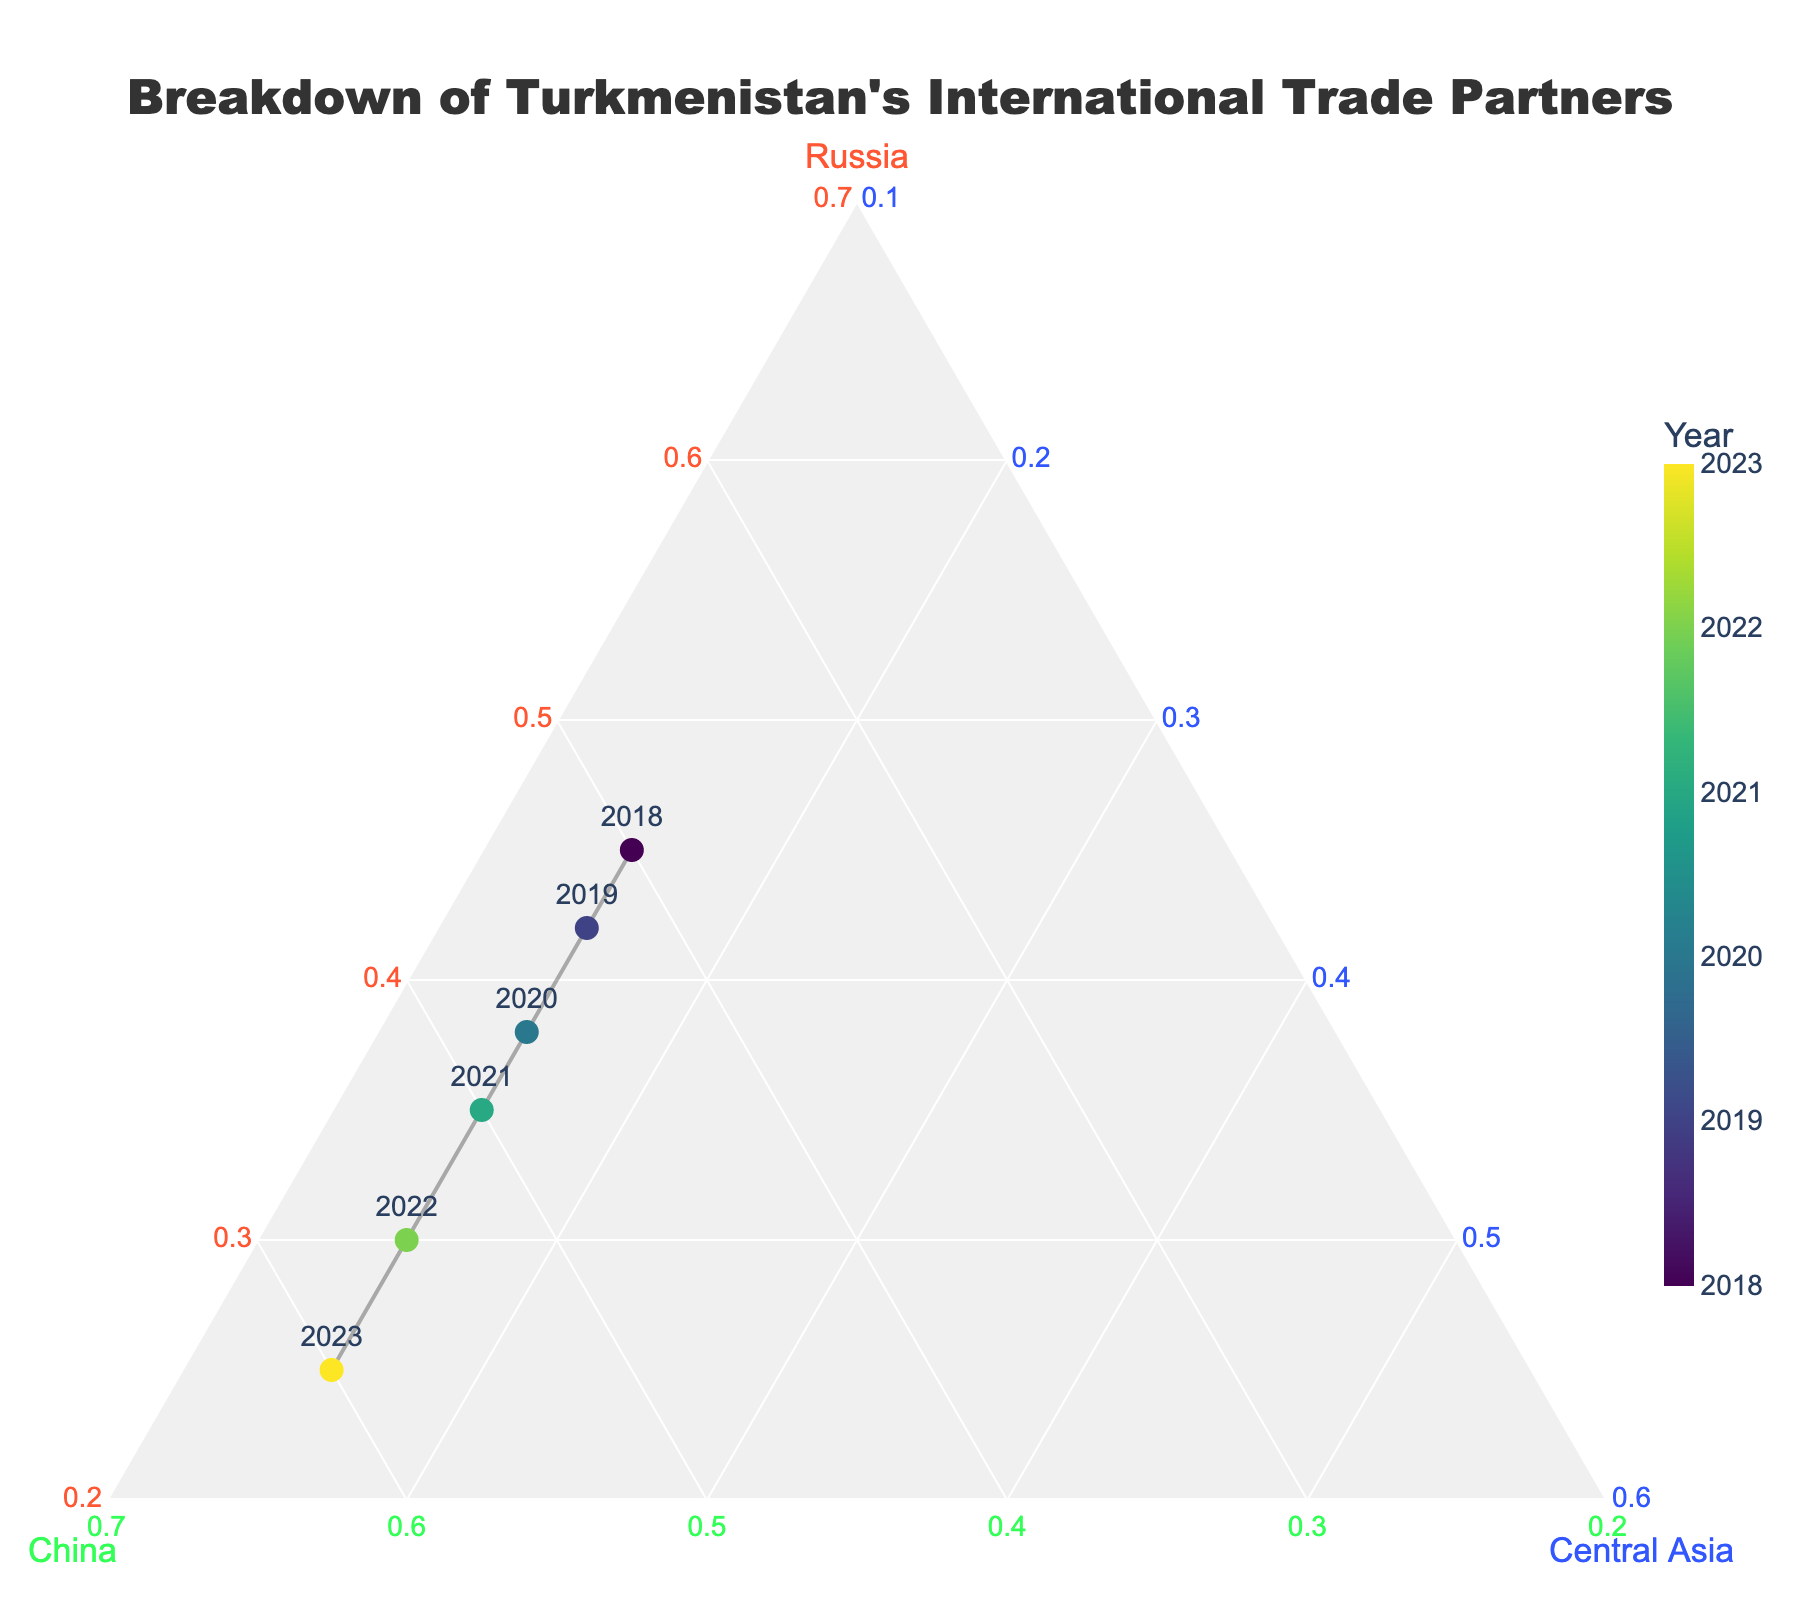what is the title of the figure? The title is located at the top center of the figure and reads "Breakdown of Turkmenistan's International Trade Partners".
Answer: Breakdown of Turkmenistan's International Trade Partners how many data points are in the figure? The figure contains one data point for each year from 2018 to 2023, so there are 6 data points in total.
Answer: 6 which year has the highest trade with China? The color scale of the markers indicates the year, and the marker with the highest value on the China axis corresponds to the year 2023.
Answer: 2023 what is the sum of the normalized values for Russia and Central Asia in 2020? In a ternary plot, the sum of the normalized values for Russia (a), China (b), and Central Asia (c) for any given year is always 1. Since China’s normalized value is 0.47 in 2020, the sum of Russia and Central Asia is 1 - 0.47 = 0.53.
Answer: 0.53 what trend do you observe in Turkmenistan’s trade with Russia from 2018 to 2023? By examining the markers and lines on the Russia axis from 2018 to 2023, it is evident that the normalized values for Russia decrease over these years, indicating a declining trend.
Answer: declining trend in which year were Turkmenistan's trade proportions with Russia and China equal? The values for Russia and China were closest to each other in 2019, where the normalized values for Russia were 0.42 and China were 0.43, which are nearly equal.
Answer: 2019 how does Turkmenistan's trade with Central Asian countries change from 2018 to 2023? The normalized values for Central Asia remain constant at 0.15 throughout this period, indicating no change over the years.
Answer: no change between which years did Turkmenistan's trade with China see the most significant increase? By comparing the normalized values for China across years, the most significant increase is observed between 2018 (0.40) and 2019 (0.43), and further between 2019 (0.43) and 2020 (0.47).
Answer: between 2019 and 2020 what is the ratio of Turkmenistan's trade with China to its trade with Russia in 2023? In 2023, the normalized values for China and Russia are 0.60 and 0.25, respectively. The ratio is 0.60 / 0.25 = 2.4.
Answer: 2.4 